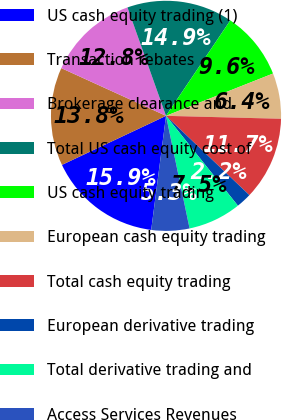<chart> <loc_0><loc_0><loc_500><loc_500><pie_chart><fcel>US cash equity trading (1)<fcel>Transaction rebates<fcel>Brokerage clearance and<fcel>Total US cash equity cost of<fcel>US cash equity trading<fcel>European cash equity trading<fcel>Total cash equity trading<fcel>European derivative trading<fcel>Total derivative trading and<fcel>Access Services Revenues<nl><fcel>15.94%<fcel>13.82%<fcel>12.76%<fcel>14.88%<fcel>9.58%<fcel>6.4%<fcel>11.7%<fcel>2.16%<fcel>7.46%<fcel>5.34%<nl></chart> 